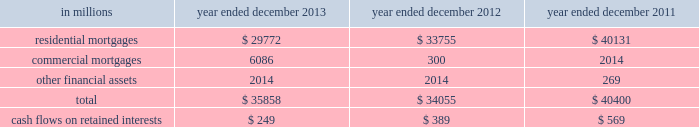Notes to consolidated financial statements note 10 .
Securitization activities the firm securitizes residential and commercial mortgages , corporate bonds , loans and other types of financial assets by selling these assets to securitization vehicles ( e.g. , trusts , corporate entities and limited liability companies ) or through a resecuritization .
The firm acts as underwriter of the beneficial interests that are sold to investors .
The firm 2019s residential mortgage securitizations are substantially all in connection with government agency securitizations .
Beneficial interests issued by securitization entities are debt or equity securities that give the investors rights to receive all or portions of specified cash inflows to a securitization vehicle and include senior and subordinated interests in principal , interest and/or other cash inflows .
The proceeds from the sale of beneficial interests are used to pay the transferor for the financial assets sold to the securitization vehicle or to purchase securities which serve as collateral .
The firm accounts for a securitization as a sale when it has relinquished control over the transferred assets .
Prior to securitization , the firm accounts for assets pending transfer at fair value and therefore does not typically recognize significant gains or losses upon the transfer of assets .
Net revenues from underwriting activities are recognized in connection with the sales of the underlying beneficial interests to investors .
For transfers of assets that are not accounted for as sales , the assets remain in 201cfinancial instruments owned , at fair value 201d and the transfer is accounted for as a collateralized financing , with the related interest expense recognized over the life of the transaction .
See notes 9 and 23 for further information about collateralized financings and interest expense , respectively .
The firm generally receives cash in exchange for the transferred assets but may also have continuing involvement with transferred assets , including ownership of beneficial interests in securitized financial assets , primarily in the form of senior or subordinated securities .
The firm may also purchase senior or subordinated securities issued by securitization vehicles ( which are typically vies ) in connection with secondary market-making activities .
The primary risks included in beneficial interests and other interests from the firm 2019s continuing involvement with securitization vehicles are the performance of the underlying collateral , the position of the firm 2019s investment in the capital structure of the securitization vehicle and the market yield for the security .
These interests are accounted for at fair value and are included in 201cfinancial instruments owned , at fair value 201d and are generally classified in level 2 of the fair value hierarchy .
See notes 5 through 8 for further information about fair value measurements .
The table below presents the amount of financial assets securitized and the cash flows received on retained interests in securitization entities in which the firm had continuing involvement. .
Goldman sachs 2013 annual report 165 .
In millions for 2013 , 2012 , and 2011 , what was the total cash flows on retained interests? 
Computations: table_sum(cash flows on retained interests, none)
Answer: 1207.0. 